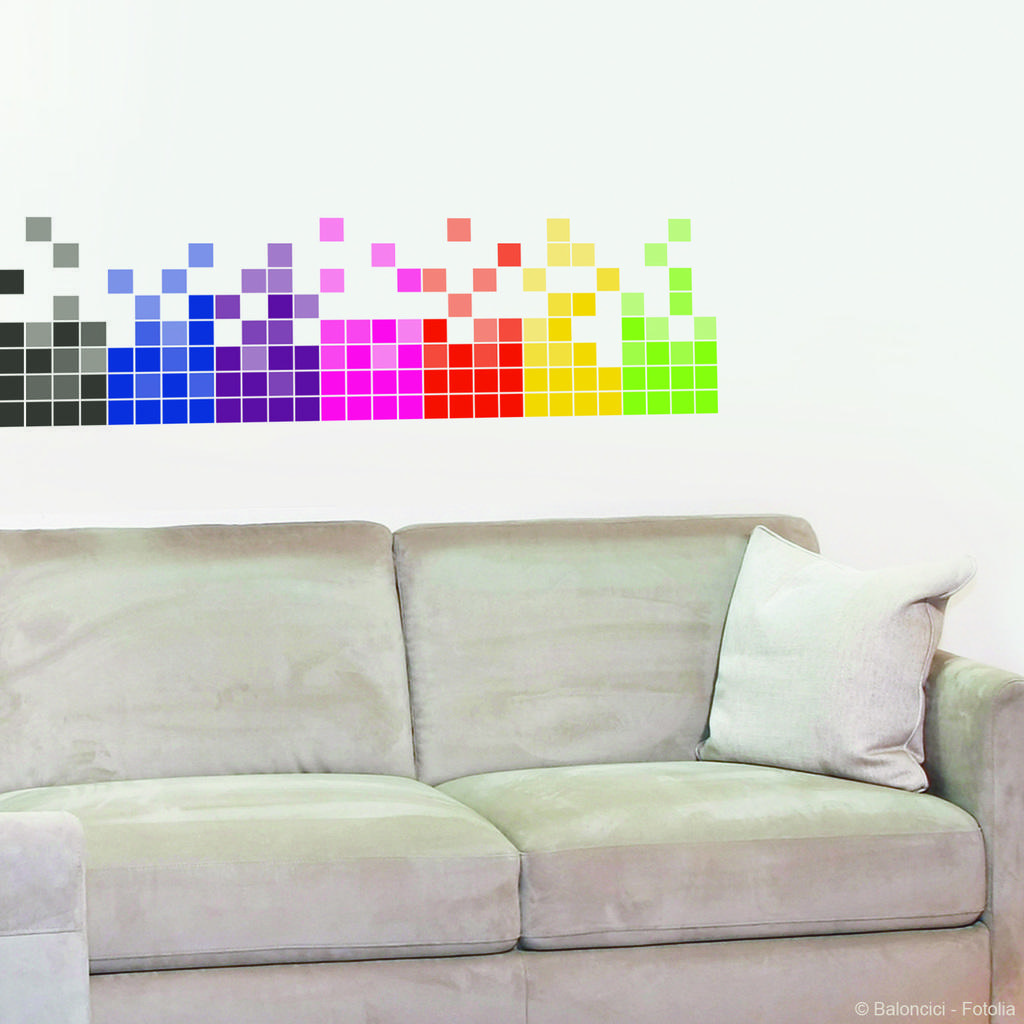How would you summarize this image in a sentence or two? Here in this picture you can see a sofa and a white pillow. In the background there are some colors colors cubes wallpaper. 